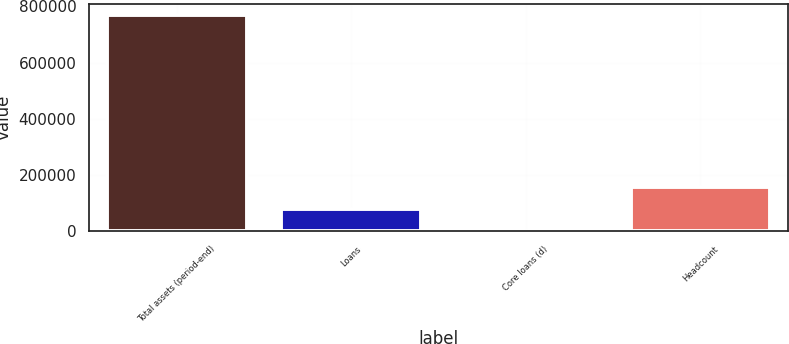Convert chart to OTSL. <chart><loc_0><loc_0><loc_500><loc_500><bar_chart><fcel>Total assets (period-end)<fcel>Loans<fcel>Core loans (d)<fcel>Headcount<nl><fcel>768204<fcel>78784.2<fcel>2182<fcel>155386<nl></chart> 